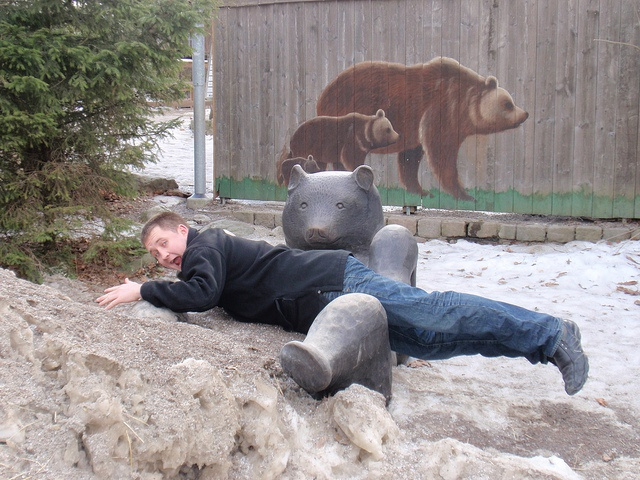Describe the objects in this image and their specific colors. I can see people in gray and black tones, bear in gray and darkgray tones, bear in gray and darkgray tones, and bear in gray, darkgray, and lightgray tones in this image. 